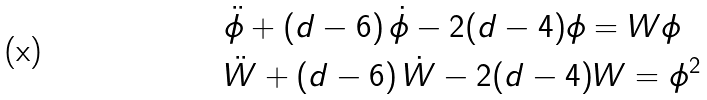Convert formula to latex. <formula><loc_0><loc_0><loc_500><loc_500>& \ddot { \phi } + ( d - 6 ) \, \dot { \phi } - 2 ( d - 4 ) \phi = W \phi \\ & \ddot { W } + ( d - 6 ) \, \dot { W } - 2 ( d - 4 ) W = \phi ^ { 2 } \\</formula> 